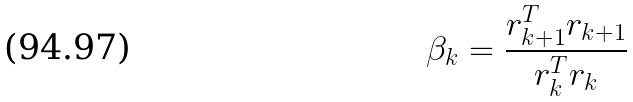Convert formula to latex. <formula><loc_0><loc_0><loc_500><loc_500>\beta _ { k } = \frac { r _ { k + 1 } ^ { T } r _ { k + 1 } } { r _ { k } ^ { T } r _ { k } }</formula> 